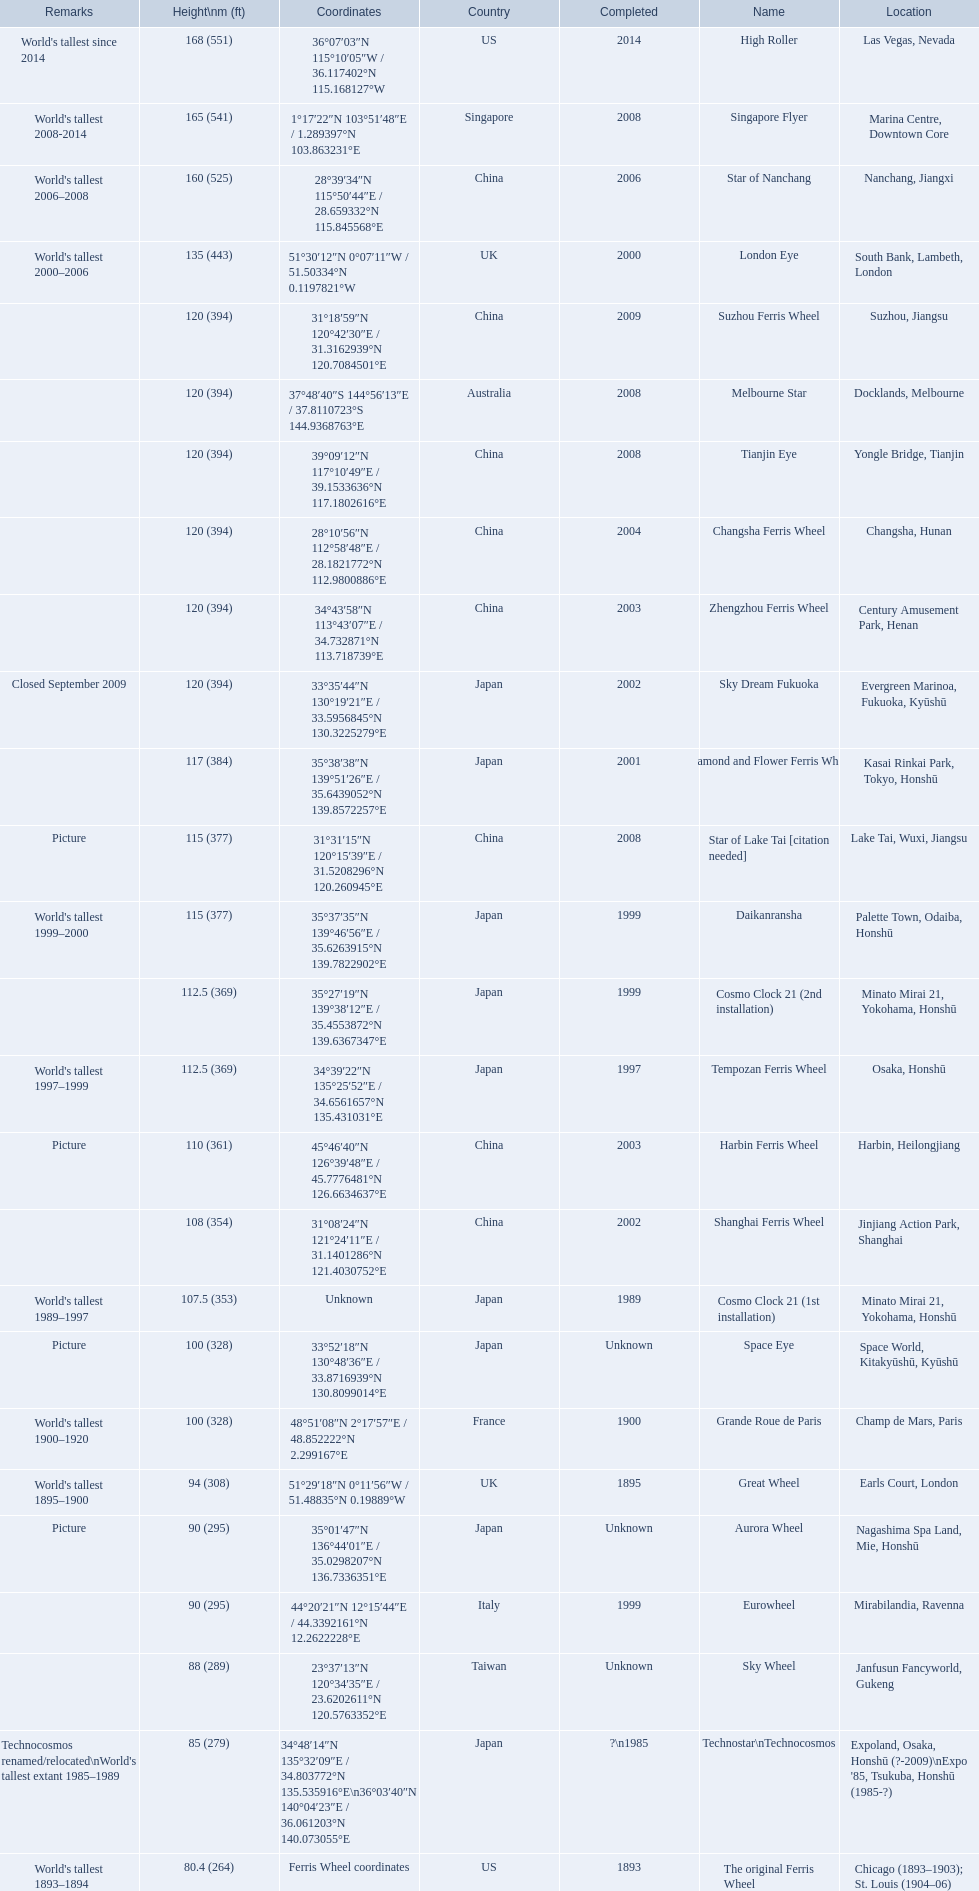What are all of the ferris wheels? High Roller, Singapore Flyer, Star of Nanchang, London Eye, Suzhou Ferris Wheel, Melbourne Star, Tianjin Eye, Changsha Ferris Wheel, Zhengzhou Ferris Wheel, Sky Dream Fukuoka, Diamond and Flower Ferris Wheel, Star of Lake Tai [citation needed], Daikanransha, Cosmo Clock 21 (2nd installation), Tempozan Ferris Wheel, Harbin Ferris Wheel, Shanghai Ferris Wheel, Cosmo Clock 21 (1st installation), Space Eye, Grande Roue de Paris, Great Wheel, Aurora Wheel, Eurowheel, Sky Wheel, Technostar\nTechnocosmos, The original Ferris Wheel. And when were they completed? 2014, 2008, 2006, 2000, 2009, 2008, 2008, 2004, 2003, 2002, 2001, 2008, 1999, 1999, 1997, 2003, 2002, 1989, Unknown, 1900, 1895, Unknown, 1999, Unknown, ?\n1985, 1893. And among star of lake tai, star of nanchang, and melbourne star, which ferris wheel is oldest? Star of Nanchang. 